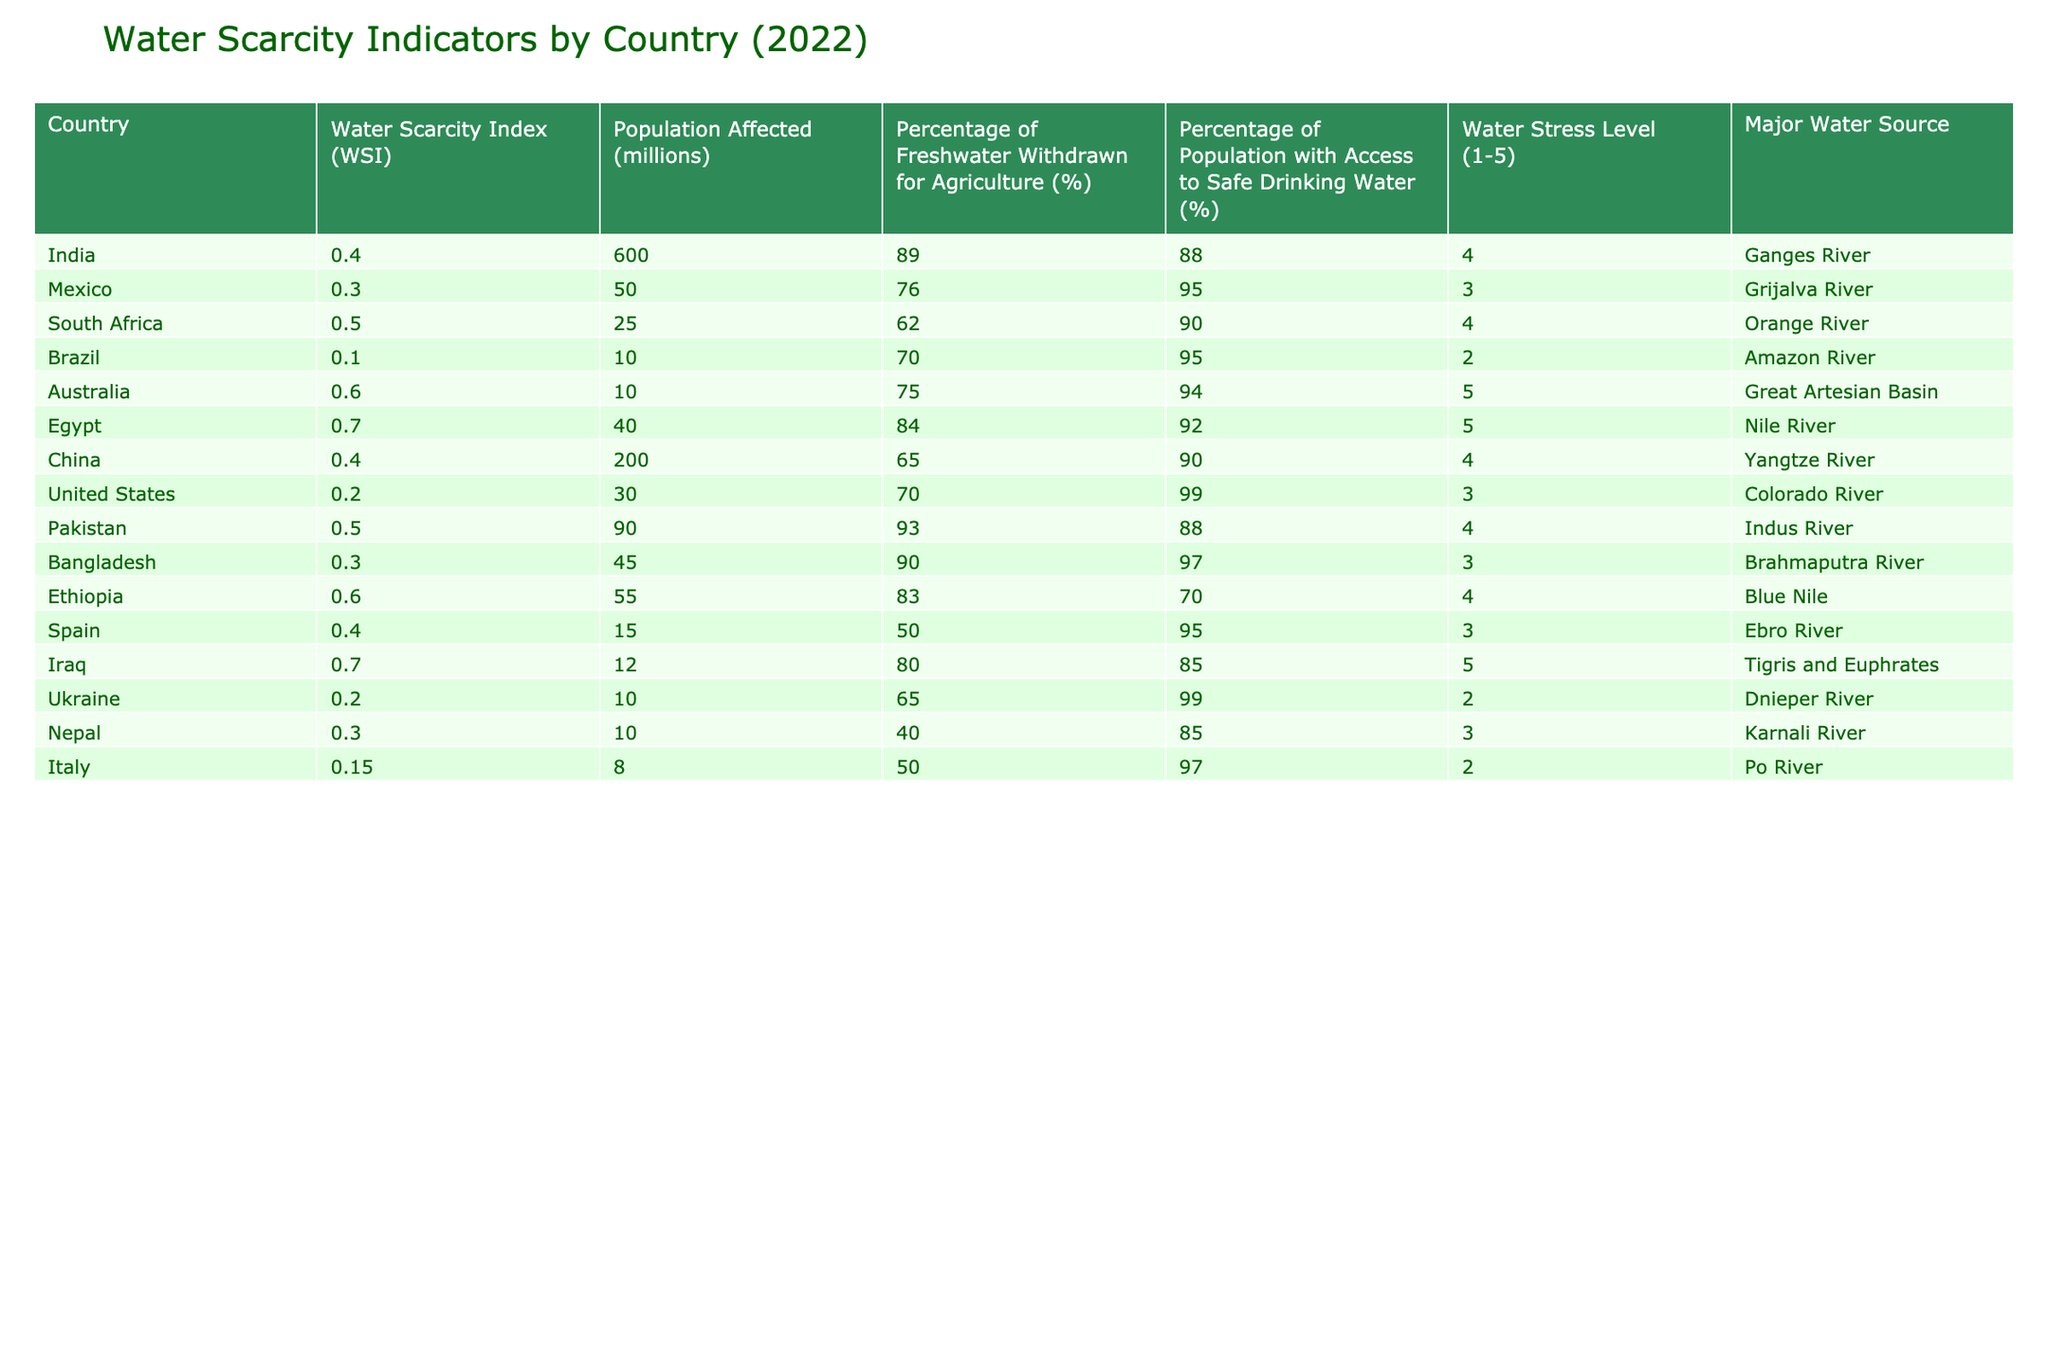What is the Water Scarcity Index (WSI) for Brazil? Brazil's Water Scarcity Index (WSI) is found in the corresponding row in the table. The value listed next to Brazil is 0.1.
Answer: 0.1 How many millions of people are affected by water scarcity in India? By looking at the row for India in the table, the number of people affected by water scarcity is given as 600 million.
Answer: 600 million Which country has the lowest percentage of freshwater withdrawn for agriculture? Checking the table, we compare the percentages for all countries. Brazil has the lowest percentage at 70%.
Answer: 70% Is the percentage of the population with access to safe drinking water in Mexico greater than in Bangladesh? The percentage for Mexico is 95% and for Bangladesh, it is 97%. Since 95% is not greater than 97%, the statement is false.
Answer: No What is the average Water Scarcity Index (WSI) for the countries listed? To calculate the average, sum all WSI values (0.4 + 0.3 + 0.5 + 0.1 + 0.6 + 0.7 + 0.4 + 0.2 + 0.5 + 0.3 + 0.6 + 0.4 + 0.7 + 0.2 + 0.3 + 0.15 = 0.485) and divide by 15 (the number of countries), which equals approximately 0.485.
Answer: 0.485 Which country has the highest water stress level? The water stress levels are found in the column for each country. The maximum level is 5, observed in Australia and Egypt.
Answer: Australia and Egypt What is the combined population affected by water scarcity in South Africa and Pakistan? Adding the affected populations together gives (25 million for South Africa + 90 million for Pakistan), totaling 115 million people affected.
Answer: 115 million Does the country with the highest percentage of freshwater withdrawn for agriculture also have a high population affected? India has the highest percentage (89%) and affects 600 million people, confirming the fact is true.
Answer: Yes What is the major water source for Iraq? According to the table, the major water source for Iraq is the Tigris and Euphrates rivers, as listed in the corresponding row.
Answer: Tigris and Euphrates 